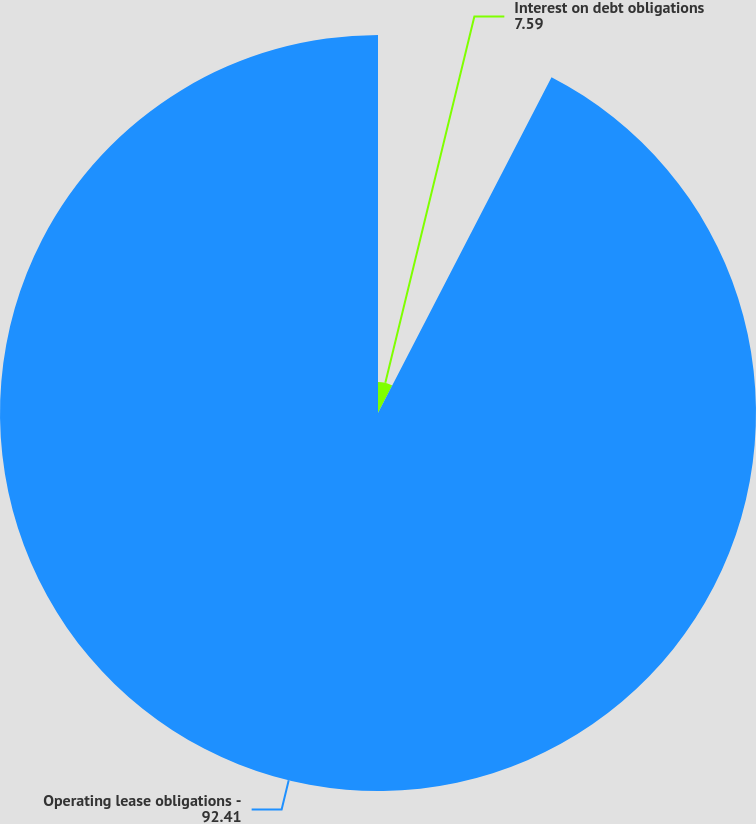Convert chart. <chart><loc_0><loc_0><loc_500><loc_500><pie_chart><fcel>Interest on debt obligations<fcel>Operating lease obligations -<nl><fcel>7.59%<fcel>92.41%<nl></chart> 